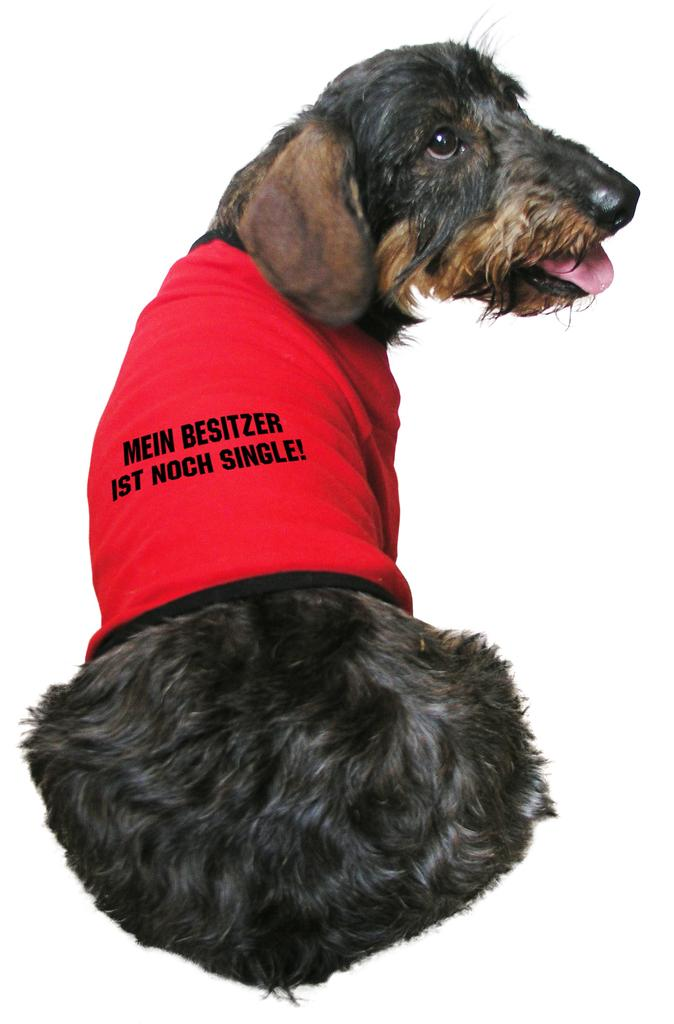What type of animal is in the image? There is a dog in the image. What color is the dog? The dog is black in color. Is the dog wearing any clothing in the image? Yes, the dog is wearing a red color T-shirt. What type of lumber is being used in the image? There is no lumber present in the image; it features a dog. 